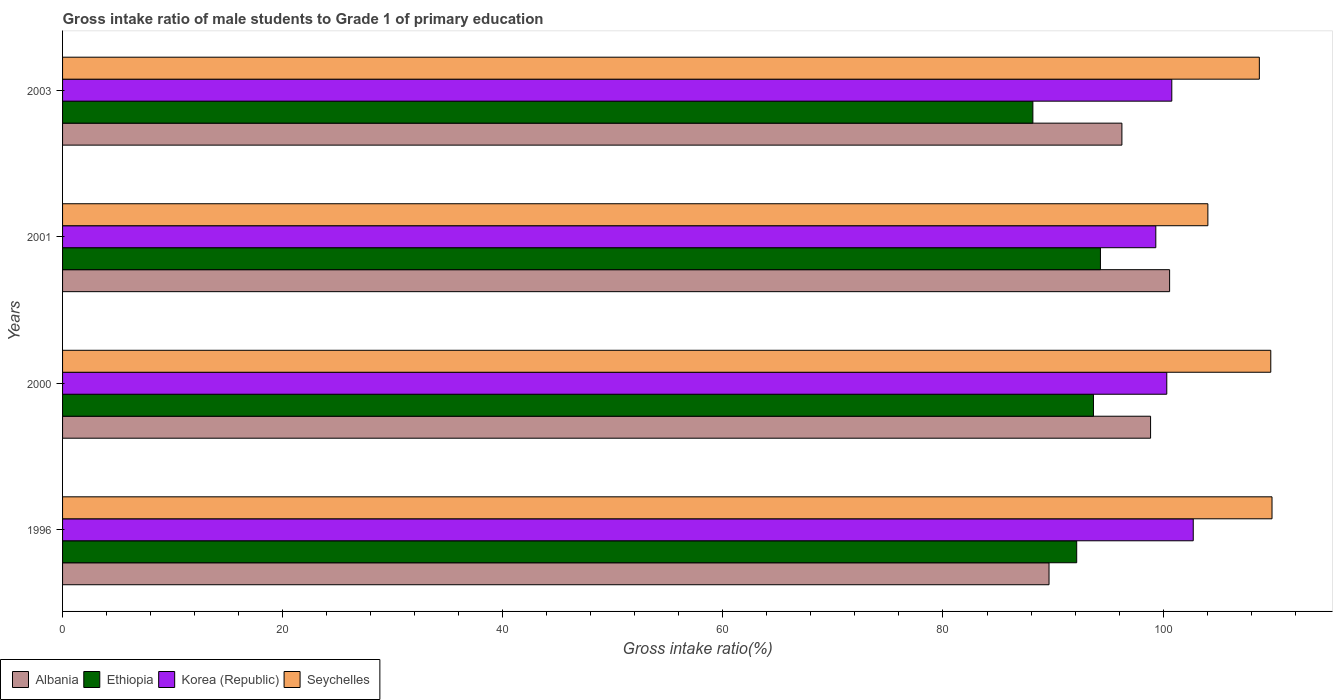How many different coloured bars are there?
Ensure brevity in your answer.  4. How many groups of bars are there?
Your answer should be compact. 4. Are the number of bars per tick equal to the number of legend labels?
Your answer should be very brief. Yes. Are the number of bars on each tick of the Y-axis equal?
Provide a short and direct response. Yes. What is the label of the 3rd group of bars from the top?
Provide a short and direct response. 2000. In how many cases, is the number of bars for a given year not equal to the number of legend labels?
Your answer should be very brief. 0. What is the gross intake ratio in Albania in 2003?
Offer a very short reply. 96.26. Across all years, what is the maximum gross intake ratio in Korea (Republic)?
Offer a very short reply. 102.74. Across all years, what is the minimum gross intake ratio in Ethiopia?
Ensure brevity in your answer.  88.17. What is the total gross intake ratio in Korea (Republic) in the graph?
Make the answer very short. 403.2. What is the difference between the gross intake ratio in Korea (Republic) in 1996 and that in 2001?
Provide a succinct answer. 3.4. What is the difference between the gross intake ratio in Korea (Republic) in 2000 and the gross intake ratio in Seychelles in 2003?
Offer a terse response. -8.41. What is the average gross intake ratio in Albania per year?
Your answer should be compact. 96.34. In the year 2003, what is the difference between the gross intake ratio in Korea (Republic) and gross intake ratio in Seychelles?
Make the answer very short. -7.95. In how many years, is the gross intake ratio in Ethiopia greater than 52 %?
Your answer should be very brief. 4. What is the ratio of the gross intake ratio in Albania in 1996 to that in 2001?
Your answer should be very brief. 0.89. What is the difference between the highest and the second highest gross intake ratio in Ethiopia?
Keep it short and to the point. 0.63. What is the difference between the highest and the lowest gross intake ratio in Seychelles?
Make the answer very short. 5.83. In how many years, is the gross intake ratio in Korea (Republic) greater than the average gross intake ratio in Korea (Republic) taken over all years?
Give a very brief answer. 1. Is the sum of the gross intake ratio in Korea (Republic) in 2001 and 2003 greater than the maximum gross intake ratio in Seychelles across all years?
Make the answer very short. Yes. What does the 1st bar from the top in 2001 represents?
Give a very brief answer. Seychelles. What does the 4th bar from the bottom in 2001 represents?
Your answer should be very brief. Seychelles. Is it the case that in every year, the sum of the gross intake ratio in Seychelles and gross intake ratio in Albania is greater than the gross intake ratio in Ethiopia?
Offer a terse response. Yes. Are all the bars in the graph horizontal?
Your response must be concise. Yes. What is the difference between two consecutive major ticks on the X-axis?
Your answer should be very brief. 20. Are the values on the major ticks of X-axis written in scientific E-notation?
Provide a short and direct response. No. How many legend labels are there?
Your answer should be compact. 4. What is the title of the graph?
Your answer should be compact. Gross intake ratio of male students to Grade 1 of primary education. What is the label or title of the X-axis?
Ensure brevity in your answer.  Gross intake ratio(%). What is the Gross intake ratio(%) in Albania in 1996?
Your answer should be compact. 89.64. What is the Gross intake ratio(%) in Ethiopia in 1996?
Provide a succinct answer. 92.15. What is the Gross intake ratio(%) of Korea (Republic) in 1996?
Keep it short and to the point. 102.74. What is the Gross intake ratio(%) in Seychelles in 1996?
Keep it short and to the point. 109.9. What is the Gross intake ratio(%) of Albania in 2000?
Make the answer very short. 98.86. What is the Gross intake ratio(%) of Ethiopia in 2000?
Offer a terse response. 93.67. What is the Gross intake ratio(%) of Korea (Republic) in 2000?
Your answer should be compact. 100.34. What is the Gross intake ratio(%) in Seychelles in 2000?
Keep it short and to the point. 109.78. What is the Gross intake ratio(%) in Albania in 2001?
Your response must be concise. 100.59. What is the Gross intake ratio(%) of Ethiopia in 2001?
Your answer should be compact. 94.31. What is the Gross intake ratio(%) of Korea (Republic) in 2001?
Ensure brevity in your answer.  99.34. What is the Gross intake ratio(%) in Seychelles in 2001?
Provide a succinct answer. 104.07. What is the Gross intake ratio(%) in Albania in 2003?
Ensure brevity in your answer.  96.26. What is the Gross intake ratio(%) in Ethiopia in 2003?
Provide a succinct answer. 88.17. What is the Gross intake ratio(%) in Korea (Republic) in 2003?
Provide a short and direct response. 100.79. What is the Gross intake ratio(%) in Seychelles in 2003?
Provide a succinct answer. 108.74. Across all years, what is the maximum Gross intake ratio(%) of Albania?
Give a very brief answer. 100.59. Across all years, what is the maximum Gross intake ratio(%) in Ethiopia?
Make the answer very short. 94.31. Across all years, what is the maximum Gross intake ratio(%) in Korea (Republic)?
Provide a succinct answer. 102.74. Across all years, what is the maximum Gross intake ratio(%) of Seychelles?
Give a very brief answer. 109.9. Across all years, what is the minimum Gross intake ratio(%) in Albania?
Ensure brevity in your answer.  89.64. Across all years, what is the minimum Gross intake ratio(%) in Ethiopia?
Offer a terse response. 88.17. Across all years, what is the minimum Gross intake ratio(%) in Korea (Republic)?
Your answer should be compact. 99.34. Across all years, what is the minimum Gross intake ratio(%) of Seychelles?
Keep it short and to the point. 104.07. What is the total Gross intake ratio(%) in Albania in the graph?
Provide a succinct answer. 385.35. What is the total Gross intake ratio(%) in Ethiopia in the graph?
Keep it short and to the point. 368.3. What is the total Gross intake ratio(%) of Korea (Republic) in the graph?
Your answer should be compact. 403.2. What is the total Gross intake ratio(%) in Seychelles in the graph?
Provide a succinct answer. 432.49. What is the difference between the Gross intake ratio(%) of Albania in 1996 and that in 2000?
Give a very brief answer. -9.23. What is the difference between the Gross intake ratio(%) of Ethiopia in 1996 and that in 2000?
Keep it short and to the point. -1.52. What is the difference between the Gross intake ratio(%) in Korea (Republic) in 1996 and that in 2000?
Offer a very short reply. 2.41. What is the difference between the Gross intake ratio(%) of Seychelles in 1996 and that in 2000?
Your answer should be compact. 0.11. What is the difference between the Gross intake ratio(%) of Albania in 1996 and that in 2001?
Provide a succinct answer. -10.96. What is the difference between the Gross intake ratio(%) of Ethiopia in 1996 and that in 2001?
Offer a very short reply. -2.16. What is the difference between the Gross intake ratio(%) of Korea (Republic) in 1996 and that in 2001?
Keep it short and to the point. 3.4. What is the difference between the Gross intake ratio(%) in Seychelles in 1996 and that in 2001?
Your answer should be very brief. 5.83. What is the difference between the Gross intake ratio(%) of Albania in 1996 and that in 2003?
Make the answer very short. -6.62. What is the difference between the Gross intake ratio(%) in Ethiopia in 1996 and that in 2003?
Keep it short and to the point. 3.98. What is the difference between the Gross intake ratio(%) of Korea (Republic) in 1996 and that in 2003?
Give a very brief answer. 1.95. What is the difference between the Gross intake ratio(%) in Seychelles in 1996 and that in 2003?
Your answer should be compact. 1.15. What is the difference between the Gross intake ratio(%) of Albania in 2000 and that in 2001?
Your response must be concise. -1.73. What is the difference between the Gross intake ratio(%) of Ethiopia in 2000 and that in 2001?
Provide a succinct answer. -0.63. What is the difference between the Gross intake ratio(%) of Korea (Republic) in 2000 and that in 2001?
Offer a very short reply. 1. What is the difference between the Gross intake ratio(%) in Seychelles in 2000 and that in 2001?
Your answer should be compact. 5.72. What is the difference between the Gross intake ratio(%) in Albania in 2000 and that in 2003?
Provide a succinct answer. 2.61. What is the difference between the Gross intake ratio(%) of Ethiopia in 2000 and that in 2003?
Offer a terse response. 5.51. What is the difference between the Gross intake ratio(%) in Korea (Republic) in 2000 and that in 2003?
Ensure brevity in your answer.  -0.46. What is the difference between the Gross intake ratio(%) of Seychelles in 2000 and that in 2003?
Offer a very short reply. 1.04. What is the difference between the Gross intake ratio(%) of Albania in 2001 and that in 2003?
Your response must be concise. 4.33. What is the difference between the Gross intake ratio(%) in Ethiopia in 2001 and that in 2003?
Make the answer very short. 6.14. What is the difference between the Gross intake ratio(%) in Korea (Republic) in 2001 and that in 2003?
Your response must be concise. -1.45. What is the difference between the Gross intake ratio(%) in Seychelles in 2001 and that in 2003?
Provide a succinct answer. -4.68. What is the difference between the Gross intake ratio(%) of Albania in 1996 and the Gross intake ratio(%) of Ethiopia in 2000?
Make the answer very short. -4.04. What is the difference between the Gross intake ratio(%) of Albania in 1996 and the Gross intake ratio(%) of Korea (Republic) in 2000?
Your response must be concise. -10.7. What is the difference between the Gross intake ratio(%) in Albania in 1996 and the Gross intake ratio(%) in Seychelles in 2000?
Your response must be concise. -20.15. What is the difference between the Gross intake ratio(%) of Ethiopia in 1996 and the Gross intake ratio(%) of Korea (Republic) in 2000?
Make the answer very short. -8.19. What is the difference between the Gross intake ratio(%) of Ethiopia in 1996 and the Gross intake ratio(%) of Seychelles in 2000?
Give a very brief answer. -17.63. What is the difference between the Gross intake ratio(%) of Korea (Republic) in 1996 and the Gross intake ratio(%) of Seychelles in 2000?
Provide a succinct answer. -7.04. What is the difference between the Gross intake ratio(%) of Albania in 1996 and the Gross intake ratio(%) of Ethiopia in 2001?
Keep it short and to the point. -4.67. What is the difference between the Gross intake ratio(%) of Albania in 1996 and the Gross intake ratio(%) of Korea (Republic) in 2001?
Provide a short and direct response. -9.7. What is the difference between the Gross intake ratio(%) of Albania in 1996 and the Gross intake ratio(%) of Seychelles in 2001?
Make the answer very short. -14.43. What is the difference between the Gross intake ratio(%) of Ethiopia in 1996 and the Gross intake ratio(%) of Korea (Republic) in 2001?
Keep it short and to the point. -7.19. What is the difference between the Gross intake ratio(%) in Ethiopia in 1996 and the Gross intake ratio(%) in Seychelles in 2001?
Give a very brief answer. -11.92. What is the difference between the Gross intake ratio(%) in Korea (Republic) in 1996 and the Gross intake ratio(%) in Seychelles in 2001?
Offer a very short reply. -1.33. What is the difference between the Gross intake ratio(%) of Albania in 1996 and the Gross intake ratio(%) of Ethiopia in 2003?
Your response must be concise. 1.47. What is the difference between the Gross intake ratio(%) of Albania in 1996 and the Gross intake ratio(%) of Korea (Republic) in 2003?
Give a very brief answer. -11.15. What is the difference between the Gross intake ratio(%) of Albania in 1996 and the Gross intake ratio(%) of Seychelles in 2003?
Your answer should be very brief. -19.11. What is the difference between the Gross intake ratio(%) of Ethiopia in 1996 and the Gross intake ratio(%) of Korea (Republic) in 2003?
Offer a very short reply. -8.64. What is the difference between the Gross intake ratio(%) of Ethiopia in 1996 and the Gross intake ratio(%) of Seychelles in 2003?
Give a very brief answer. -16.6. What is the difference between the Gross intake ratio(%) of Korea (Republic) in 1996 and the Gross intake ratio(%) of Seychelles in 2003?
Make the answer very short. -6. What is the difference between the Gross intake ratio(%) in Albania in 2000 and the Gross intake ratio(%) in Ethiopia in 2001?
Offer a terse response. 4.56. What is the difference between the Gross intake ratio(%) in Albania in 2000 and the Gross intake ratio(%) in Korea (Republic) in 2001?
Offer a terse response. -0.48. What is the difference between the Gross intake ratio(%) in Albania in 2000 and the Gross intake ratio(%) in Seychelles in 2001?
Keep it short and to the point. -5.21. What is the difference between the Gross intake ratio(%) of Ethiopia in 2000 and the Gross intake ratio(%) of Korea (Republic) in 2001?
Ensure brevity in your answer.  -5.67. What is the difference between the Gross intake ratio(%) in Ethiopia in 2000 and the Gross intake ratio(%) in Seychelles in 2001?
Your answer should be compact. -10.4. What is the difference between the Gross intake ratio(%) of Korea (Republic) in 2000 and the Gross intake ratio(%) of Seychelles in 2001?
Provide a succinct answer. -3.73. What is the difference between the Gross intake ratio(%) of Albania in 2000 and the Gross intake ratio(%) of Ethiopia in 2003?
Provide a short and direct response. 10.7. What is the difference between the Gross intake ratio(%) of Albania in 2000 and the Gross intake ratio(%) of Korea (Republic) in 2003?
Offer a very short reply. -1.93. What is the difference between the Gross intake ratio(%) of Albania in 2000 and the Gross intake ratio(%) of Seychelles in 2003?
Your answer should be very brief. -9.88. What is the difference between the Gross intake ratio(%) of Ethiopia in 2000 and the Gross intake ratio(%) of Korea (Republic) in 2003?
Your response must be concise. -7.12. What is the difference between the Gross intake ratio(%) of Ethiopia in 2000 and the Gross intake ratio(%) of Seychelles in 2003?
Your answer should be compact. -15.07. What is the difference between the Gross intake ratio(%) in Korea (Republic) in 2000 and the Gross intake ratio(%) in Seychelles in 2003?
Give a very brief answer. -8.41. What is the difference between the Gross intake ratio(%) of Albania in 2001 and the Gross intake ratio(%) of Ethiopia in 2003?
Provide a succinct answer. 12.42. What is the difference between the Gross intake ratio(%) in Albania in 2001 and the Gross intake ratio(%) in Korea (Republic) in 2003?
Make the answer very short. -0.2. What is the difference between the Gross intake ratio(%) in Albania in 2001 and the Gross intake ratio(%) in Seychelles in 2003?
Keep it short and to the point. -8.15. What is the difference between the Gross intake ratio(%) in Ethiopia in 2001 and the Gross intake ratio(%) in Korea (Republic) in 2003?
Provide a succinct answer. -6.48. What is the difference between the Gross intake ratio(%) in Ethiopia in 2001 and the Gross intake ratio(%) in Seychelles in 2003?
Keep it short and to the point. -14.44. What is the difference between the Gross intake ratio(%) of Korea (Republic) in 2001 and the Gross intake ratio(%) of Seychelles in 2003?
Offer a very short reply. -9.41. What is the average Gross intake ratio(%) of Albania per year?
Make the answer very short. 96.34. What is the average Gross intake ratio(%) of Ethiopia per year?
Your answer should be compact. 92.07. What is the average Gross intake ratio(%) of Korea (Republic) per year?
Make the answer very short. 100.8. What is the average Gross intake ratio(%) in Seychelles per year?
Offer a very short reply. 108.12. In the year 1996, what is the difference between the Gross intake ratio(%) in Albania and Gross intake ratio(%) in Ethiopia?
Your response must be concise. -2.51. In the year 1996, what is the difference between the Gross intake ratio(%) of Albania and Gross intake ratio(%) of Korea (Republic)?
Ensure brevity in your answer.  -13.1. In the year 1996, what is the difference between the Gross intake ratio(%) of Albania and Gross intake ratio(%) of Seychelles?
Provide a succinct answer. -20.26. In the year 1996, what is the difference between the Gross intake ratio(%) in Ethiopia and Gross intake ratio(%) in Korea (Republic)?
Your answer should be very brief. -10.59. In the year 1996, what is the difference between the Gross intake ratio(%) in Ethiopia and Gross intake ratio(%) in Seychelles?
Your response must be concise. -17.75. In the year 1996, what is the difference between the Gross intake ratio(%) in Korea (Republic) and Gross intake ratio(%) in Seychelles?
Your response must be concise. -7.16. In the year 2000, what is the difference between the Gross intake ratio(%) in Albania and Gross intake ratio(%) in Ethiopia?
Give a very brief answer. 5.19. In the year 2000, what is the difference between the Gross intake ratio(%) in Albania and Gross intake ratio(%) in Korea (Republic)?
Keep it short and to the point. -1.47. In the year 2000, what is the difference between the Gross intake ratio(%) in Albania and Gross intake ratio(%) in Seychelles?
Your answer should be very brief. -10.92. In the year 2000, what is the difference between the Gross intake ratio(%) in Ethiopia and Gross intake ratio(%) in Korea (Republic)?
Offer a terse response. -6.66. In the year 2000, what is the difference between the Gross intake ratio(%) in Ethiopia and Gross intake ratio(%) in Seychelles?
Make the answer very short. -16.11. In the year 2000, what is the difference between the Gross intake ratio(%) of Korea (Republic) and Gross intake ratio(%) of Seychelles?
Provide a succinct answer. -9.45. In the year 2001, what is the difference between the Gross intake ratio(%) in Albania and Gross intake ratio(%) in Ethiopia?
Keep it short and to the point. 6.28. In the year 2001, what is the difference between the Gross intake ratio(%) of Albania and Gross intake ratio(%) of Korea (Republic)?
Provide a succinct answer. 1.25. In the year 2001, what is the difference between the Gross intake ratio(%) of Albania and Gross intake ratio(%) of Seychelles?
Offer a terse response. -3.48. In the year 2001, what is the difference between the Gross intake ratio(%) of Ethiopia and Gross intake ratio(%) of Korea (Republic)?
Keep it short and to the point. -5.03. In the year 2001, what is the difference between the Gross intake ratio(%) of Ethiopia and Gross intake ratio(%) of Seychelles?
Provide a short and direct response. -9.76. In the year 2001, what is the difference between the Gross intake ratio(%) of Korea (Republic) and Gross intake ratio(%) of Seychelles?
Your answer should be compact. -4.73. In the year 2003, what is the difference between the Gross intake ratio(%) of Albania and Gross intake ratio(%) of Ethiopia?
Provide a succinct answer. 8.09. In the year 2003, what is the difference between the Gross intake ratio(%) in Albania and Gross intake ratio(%) in Korea (Republic)?
Your answer should be compact. -4.53. In the year 2003, what is the difference between the Gross intake ratio(%) in Albania and Gross intake ratio(%) in Seychelles?
Keep it short and to the point. -12.49. In the year 2003, what is the difference between the Gross intake ratio(%) in Ethiopia and Gross intake ratio(%) in Korea (Republic)?
Ensure brevity in your answer.  -12.62. In the year 2003, what is the difference between the Gross intake ratio(%) in Ethiopia and Gross intake ratio(%) in Seychelles?
Offer a terse response. -20.58. In the year 2003, what is the difference between the Gross intake ratio(%) of Korea (Republic) and Gross intake ratio(%) of Seychelles?
Give a very brief answer. -7.95. What is the ratio of the Gross intake ratio(%) of Albania in 1996 to that in 2000?
Make the answer very short. 0.91. What is the ratio of the Gross intake ratio(%) of Ethiopia in 1996 to that in 2000?
Offer a very short reply. 0.98. What is the ratio of the Gross intake ratio(%) in Korea (Republic) in 1996 to that in 2000?
Make the answer very short. 1.02. What is the ratio of the Gross intake ratio(%) of Albania in 1996 to that in 2001?
Keep it short and to the point. 0.89. What is the ratio of the Gross intake ratio(%) of Ethiopia in 1996 to that in 2001?
Ensure brevity in your answer.  0.98. What is the ratio of the Gross intake ratio(%) of Korea (Republic) in 1996 to that in 2001?
Offer a terse response. 1.03. What is the ratio of the Gross intake ratio(%) of Seychelles in 1996 to that in 2001?
Give a very brief answer. 1.06. What is the ratio of the Gross intake ratio(%) in Albania in 1996 to that in 2003?
Ensure brevity in your answer.  0.93. What is the ratio of the Gross intake ratio(%) of Ethiopia in 1996 to that in 2003?
Keep it short and to the point. 1.05. What is the ratio of the Gross intake ratio(%) in Korea (Republic) in 1996 to that in 2003?
Your answer should be very brief. 1.02. What is the ratio of the Gross intake ratio(%) in Seychelles in 1996 to that in 2003?
Offer a very short reply. 1.01. What is the ratio of the Gross intake ratio(%) of Albania in 2000 to that in 2001?
Give a very brief answer. 0.98. What is the ratio of the Gross intake ratio(%) in Ethiopia in 2000 to that in 2001?
Offer a terse response. 0.99. What is the ratio of the Gross intake ratio(%) in Seychelles in 2000 to that in 2001?
Give a very brief answer. 1.05. What is the ratio of the Gross intake ratio(%) of Albania in 2000 to that in 2003?
Provide a short and direct response. 1.03. What is the ratio of the Gross intake ratio(%) of Ethiopia in 2000 to that in 2003?
Provide a short and direct response. 1.06. What is the ratio of the Gross intake ratio(%) in Seychelles in 2000 to that in 2003?
Your response must be concise. 1.01. What is the ratio of the Gross intake ratio(%) in Albania in 2001 to that in 2003?
Give a very brief answer. 1.04. What is the ratio of the Gross intake ratio(%) in Ethiopia in 2001 to that in 2003?
Keep it short and to the point. 1.07. What is the ratio of the Gross intake ratio(%) of Korea (Republic) in 2001 to that in 2003?
Make the answer very short. 0.99. What is the ratio of the Gross intake ratio(%) in Seychelles in 2001 to that in 2003?
Ensure brevity in your answer.  0.96. What is the difference between the highest and the second highest Gross intake ratio(%) in Albania?
Ensure brevity in your answer.  1.73. What is the difference between the highest and the second highest Gross intake ratio(%) of Ethiopia?
Provide a short and direct response. 0.63. What is the difference between the highest and the second highest Gross intake ratio(%) in Korea (Republic)?
Offer a very short reply. 1.95. What is the difference between the highest and the second highest Gross intake ratio(%) in Seychelles?
Provide a short and direct response. 0.11. What is the difference between the highest and the lowest Gross intake ratio(%) in Albania?
Your response must be concise. 10.96. What is the difference between the highest and the lowest Gross intake ratio(%) of Ethiopia?
Provide a short and direct response. 6.14. What is the difference between the highest and the lowest Gross intake ratio(%) in Korea (Republic)?
Ensure brevity in your answer.  3.4. What is the difference between the highest and the lowest Gross intake ratio(%) of Seychelles?
Ensure brevity in your answer.  5.83. 